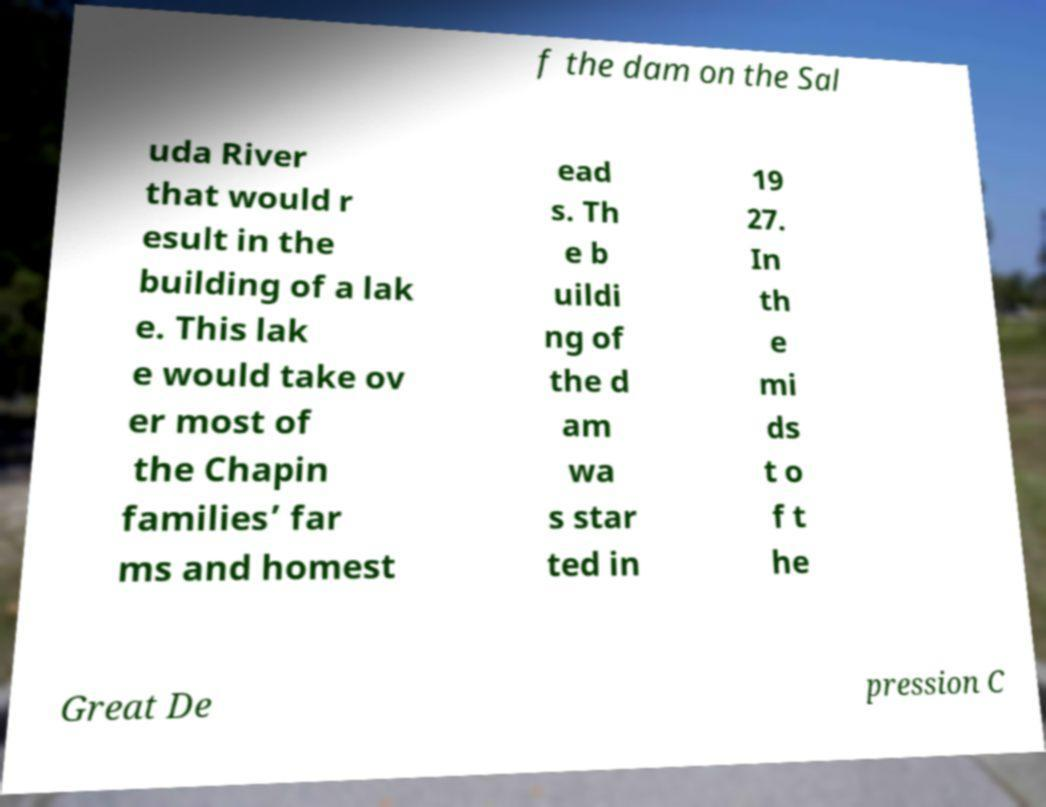There's text embedded in this image that I need extracted. Can you transcribe it verbatim? f the dam on the Sal uda River that would r esult in the building of a lak e. This lak e would take ov er most of the Chapin families’ far ms and homest ead s. Th e b uildi ng of the d am wa s star ted in 19 27. In th e mi ds t o f t he Great De pression C 